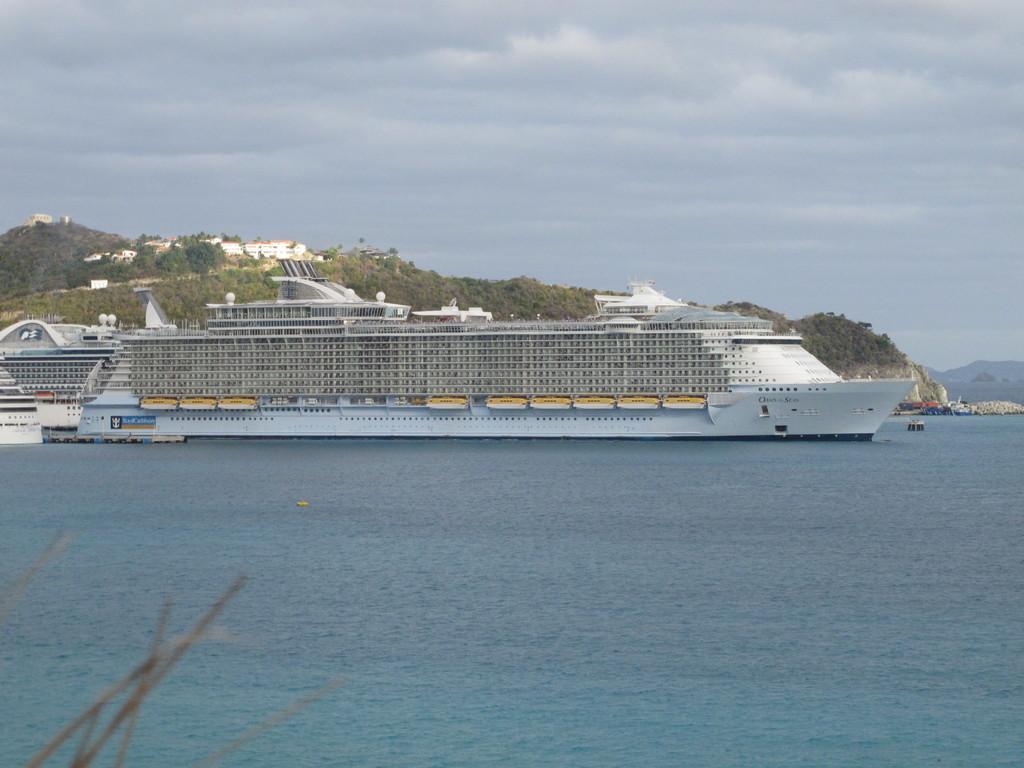How would you summarize this image in a sentence or two? In this image I can see the ship on the water. In the background I can see few trees in green color and I can also see few buildings and the sky is in white and blue color. 